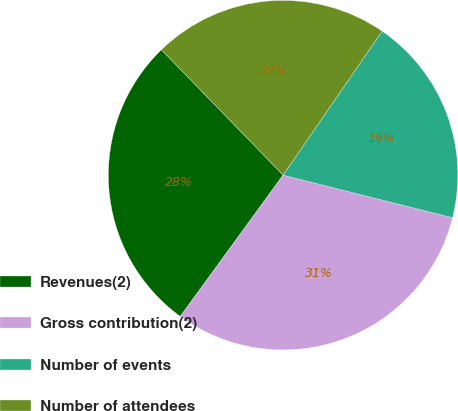<chart> <loc_0><loc_0><loc_500><loc_500><pie_chart><fcel>Revenues(2)<fcel>Gross contribution(2)<fcel>Number of events<fcel>Number of attendees<nl><fcel>27.73%<fcel>31.09%<fcel>19.33%<fcel>21.85%<nl></chart> 